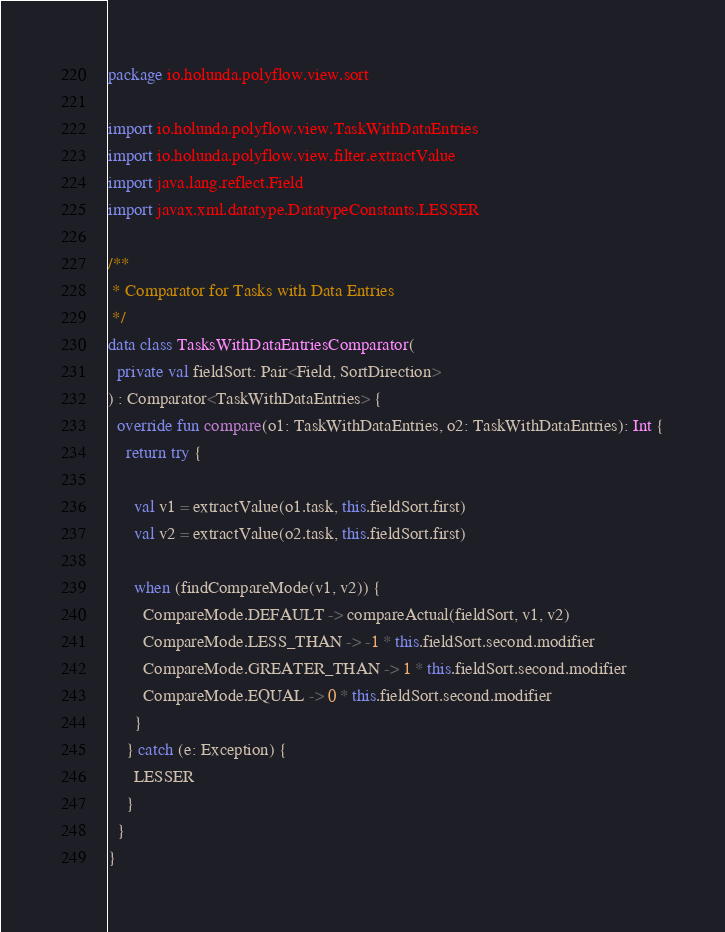<code> <loc_0><loc_0><loc_500><loc_500><_Kotlin_>package io.holunda.polyflow.view.sort

import io.holunda.polyflow.view.TaskWithDataEntries
import io.holunda.polyflow.view.filter.extractValue
import java.lang.reflect.Field
import javax.xml.datatype.DatatypeConstants.LESSER

/**
 * Comparator for Tasks with Data Entries
 */
data class TasksWithDataEntriesComparator(
  private val fieldSort: Pair<Field, SortDirection>
) : Comparator<TaskWithDataEntries> {
  override fun compare(o1: TaskWithDataEntries, o2: TaskWithDataEntries): Int {
    return try {

      val v1 = extractValue(o1.task, this.fieldSort.first)
      val v2 = extractValue(o2.task, this.fieldSort.first)

      when (findCompareMode(v1, v2)) {
        CompareMode.DEFAULT -> compareActual(fieldSort, v1, v2)
        CompareMode.LESS_THAN -> -1 * this.fieldSort.second.modifier
        CompareMode.GREATER_THAN -> 1 * this.fieldSort.second.modifier
        CompareMode.EQUAL -> 0 * this.fieldSort.second.modifier
      }
    } catch (e: Exception) {
      LESSER
    }
  }
}

</code> 